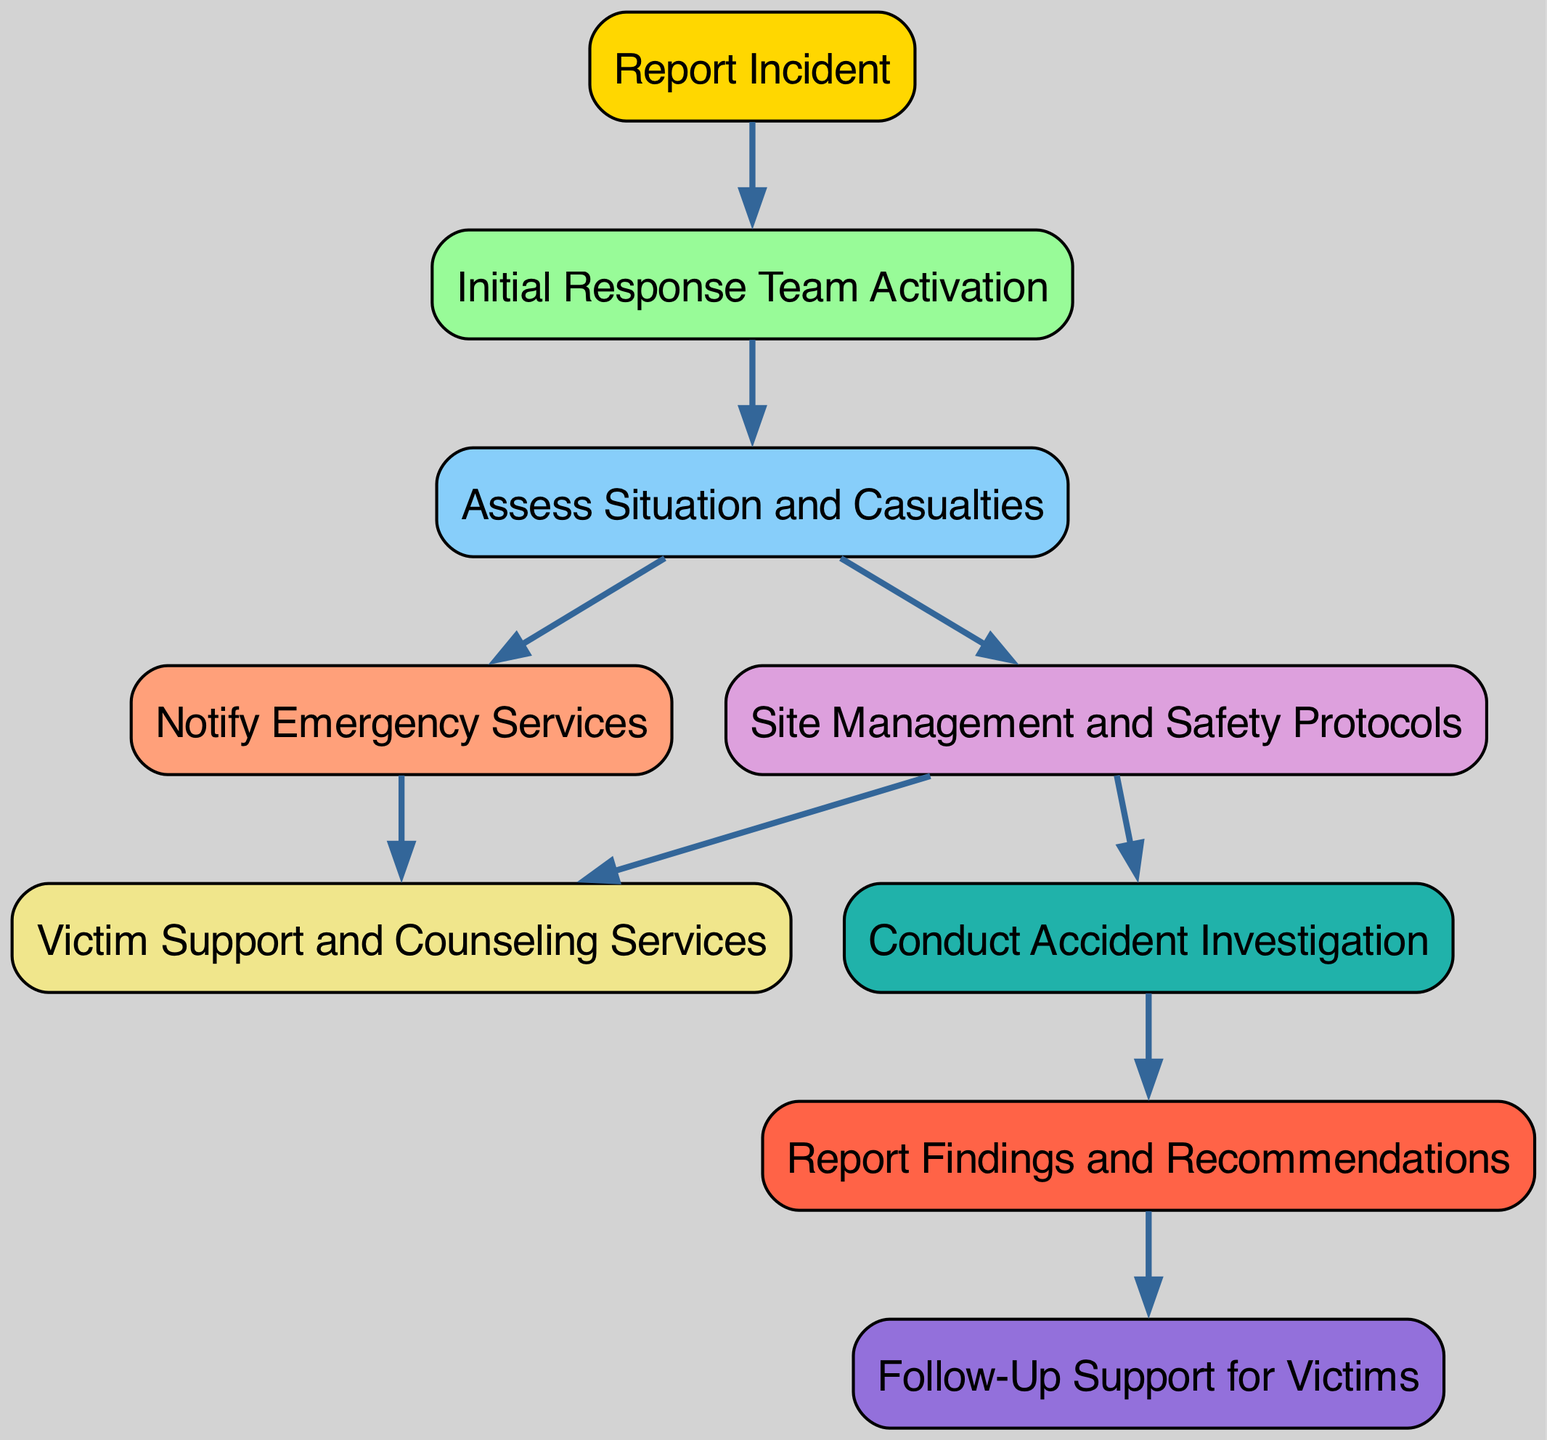What’s the first action taken after reporting an incident? The diagram shows that the first action taken after the "Report Incident" node is the "Initial Response Team Activation" node, connected directly by an edge.
Answer: Initial Response Team Activation How many nodes are in the diagram? By counting the nodes listed in the diagram data, there are a total of nine distinct nodes.
Answer: 9 Which nodes are connected to the "Assess Situation and Casualties" node? The edges from the "Assess Situation and Casualties" node lead to the "Notify Emergency Services" and "Site Management and Safety Protocols" nodes, indicated by direct connections from it in the diagram.
Answer: Notify Emergency Services, Site Management What is the last action taken in the process? The last action in the flowchart is represented by the "Follow-Up Support for Victims" node, which comes after "Report Findings and Recommendations" as indicated by the directed edge.
Answer: Follow-Up Support for Victims Which two nodes lead to "Victim Support and Counseling Services"? The "Victim Support and Counseling Services" node is reached from both the "Site Management and Safety Protocols" and "Notify Emergency Services" nodes, as shown in the diagram's edge connections.
Answer: Site Management, Notify Emergency Services What action follows the investigation step? The action that follows the "Conduct Accident Investigation" node is "Report Findings and Recommendations", which is indicated by the edge connecting these two nodes in the diagram.
Answer: Report Findings and Recommendations What type of nodes does the flowchart contain? The diagram contains only rectangular nodes which represent actions or steps in the accident response process, as specified by their node shapes.
Answer: Rectangular nodes What connects "Report Findings and Recommendations" to "Follow-Up Support for Victims"? The connection from "Report Findings and Recommendations" to "Follow-Up Support for Victims" is made by a directed edge that indicates the flow from one action to the other.
Answer: Directed edge What is the significance of "Site Management and Safety Protocols" in the process? The "Site Management and Safety Protocols" node is essential as it leads to both "Victim Support and Counseling Services" and "Conduct Accident Investigation", indicating its role in both victim assistance and ensuring safety.
Answer: Central role 